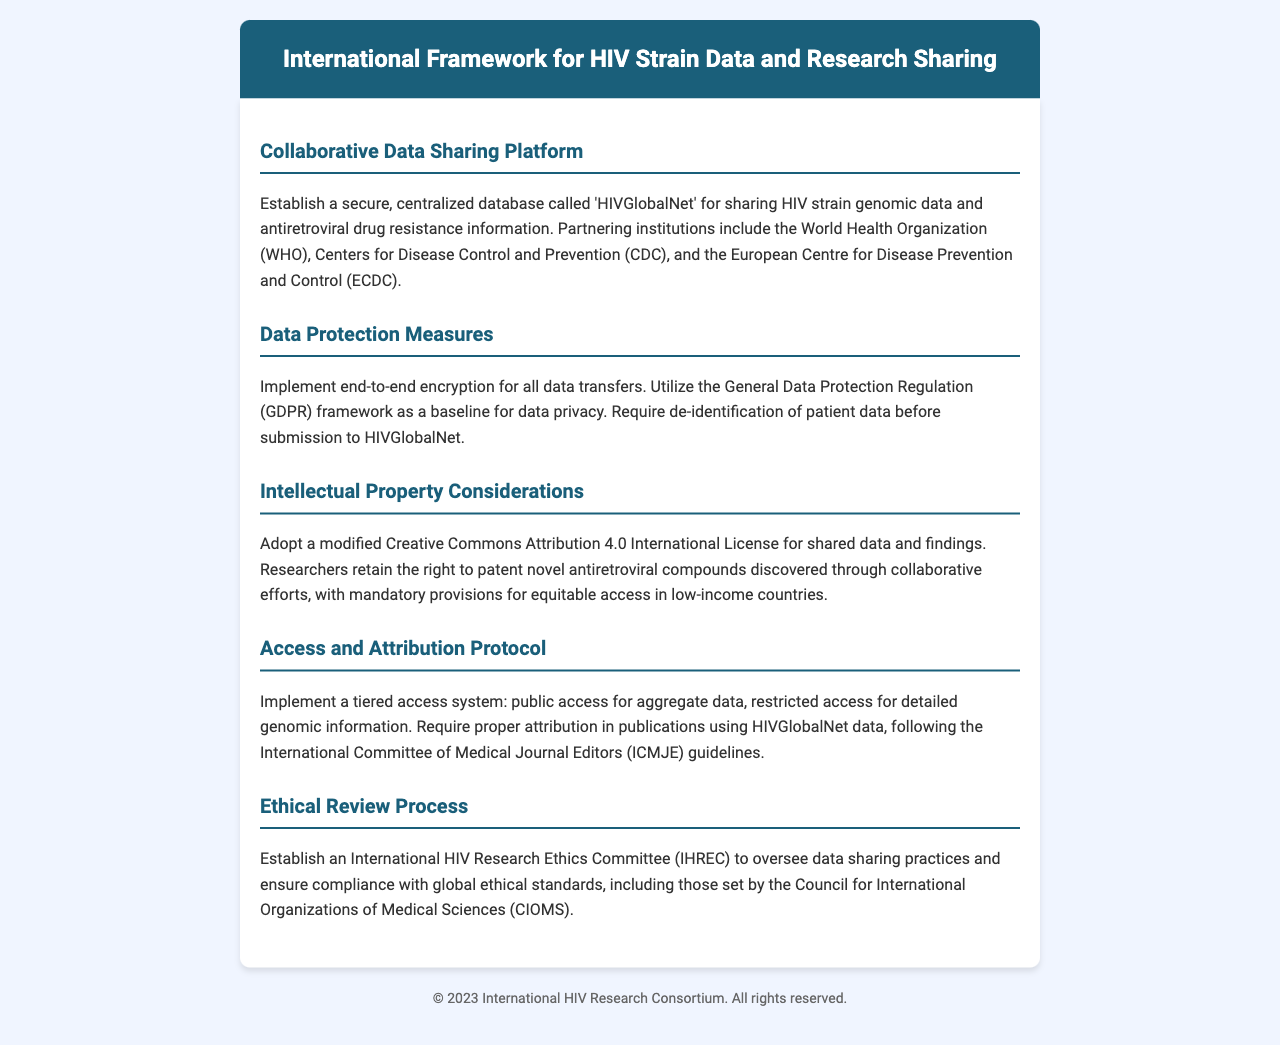What is the name of the centralized database for HIV strain data? The document specifies a centralized database called 'HIVGlobalNet' for sharing HIV strain genomic data.
Answer: HIVGlobalNet Which organizations are partnering for the data sharing framework? The partnering institutions include the World Health Organization (WHO), Centers for Disease Control and Prevention (CDC), and the European Centre for Disease Prevention and Control (ECDC).
Answer: WHO, CDC, ECDC What data protection framework is utilized as a baseline? The document mentions utilizing the General Data Protection Regulation (GDPR) framework as a baseline for data privacy.
Answer: GDPR What type of license is adopted for shared data and findings? The framework adopts a modified Creative Commons Attribution 4.0 International License for shared data and findings.
Answer: Creative Commons Attribution 4.0 What committee oversees the compliance with global ethical standards? An International HIV Research Ethics Committee (IHREC) is established to oversee data sharing practices and compliance with ethical standards.
Answer: IHREC 